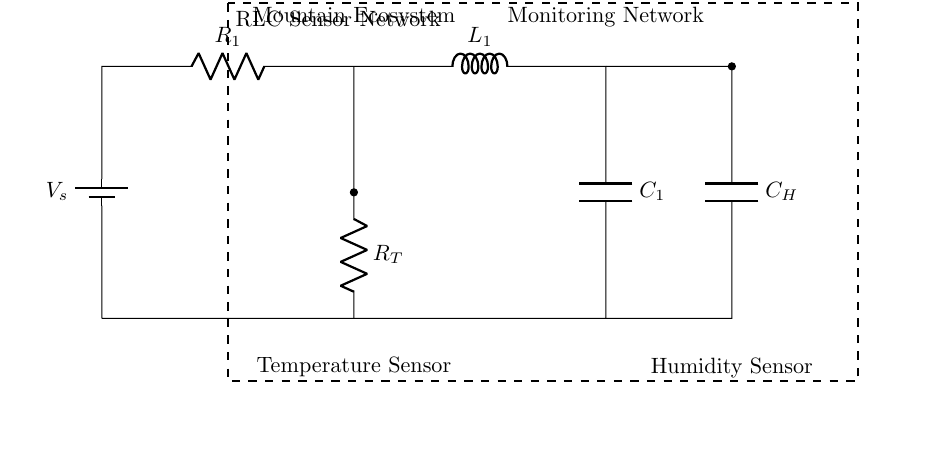What is the power supply voltage of the circuit? The circuit diagram indicates a battery symbol labeled with "V_s," which typically represents the power supply voltage. The voltage value is generally depicted nearby, but since no specific value is shown here, we can only refer to it symbolically as "V_s."
Answer: V_s What components are used for temperature and humidity sensing? In the circuit, there is a resistor labeled R_T connected in parallel with the temperature sensor, and a capacitor labeled C_H associated with the humidity sensor. Both sensors are indicated in the diagram as components specifically designated for temperature and humidity.
Answer: Resistor and Capacitor How are the temperature and humidity sensors connected within the circuit? The temperature sensor is connected directly via a resistor to the voltage source, while the humidity sensor is connected through a capacitor. This configuration implies that both sensors receive power from the same source, with components ensuring distinct roles for measuring temperature and humidity.
Answer: In parallel What is the role of the inductor in this circuit? The inductor labeled L_1 is part of the RLC circuit configuration, which serves to regulate current flow and influence phase relationships in the circuit. Here, it contributes to the overall response of the network, especially in filtering signals that may be affected by temperature and humidity changes.
Answer: Regulate current What does the dashed rectangle represent in the circuit diagram? The dashed rectangle encompasses the entire circuit and is labeled as the "RLC Sensor Network." This visually groups all components within the boundaries, indicating that they collectively function as a unit focused on monitoring the environmental parameters pertinent to the mountain ecosystem.
Answer: RLC Sensor Network How does this RLC circuit contribute to ecosystem monitoring? The RLC circuit provides an oscillatory response characterized by its resistance (R), inductance (L), and capacitance (C), which is essential for accurate temperature and humidity measurements. Such oscillations can help filter out noise, allowing for finer adjustments and hence better data acquisition vital for understanding ecosystem health.
Answer: Accurate measurements 